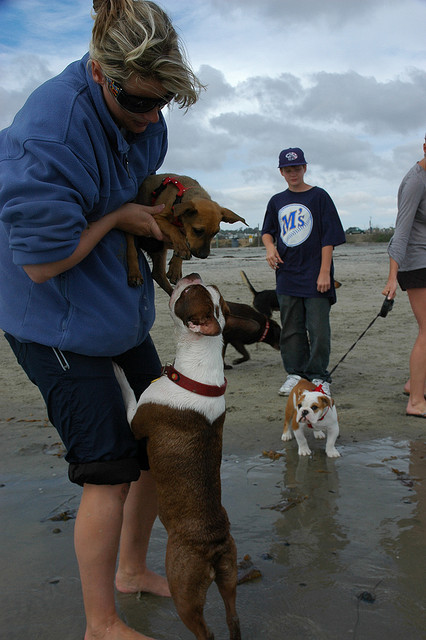<image>What is the cat's attention on? There is no cat in the image. What is the cat's attention on? There is no cat shown in the image. 